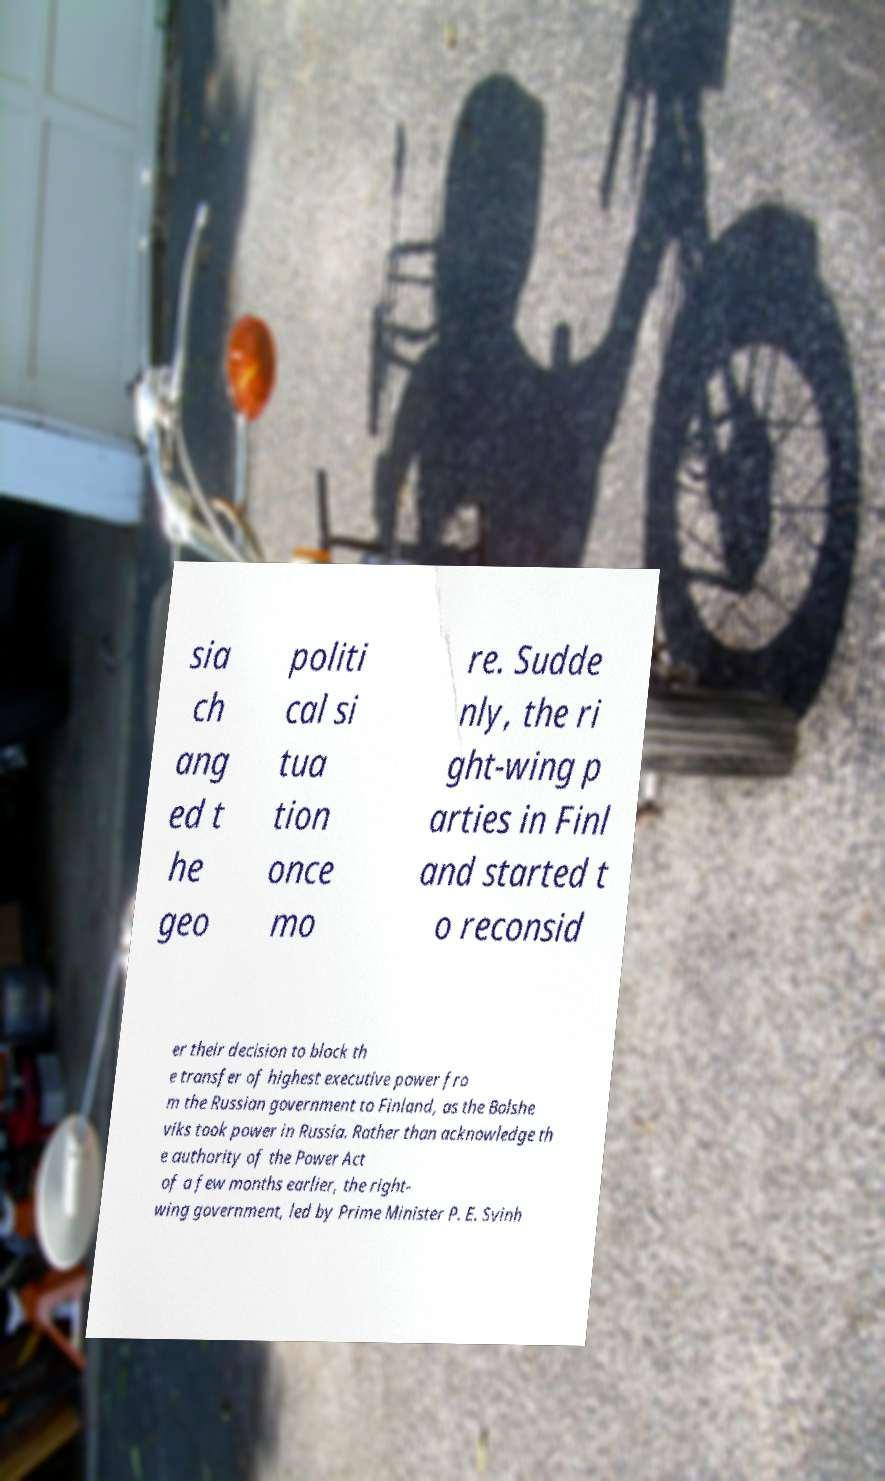Could you extract and type out the text from this image? sia ch ang ed t he geo politi cal si tua tion once mo re. Sudde nly, the ri ght-wing p arties in Finl and started t o reconsid er their decision to block th e transfer of highest executive power fro m the Russian government to Finland, as the Bolshe viks took power in Russia. Rather than acknowledge th e authority of the Power Act of a few months earlier, the right- wing government, led by Prime Minister P. E. Svinh 